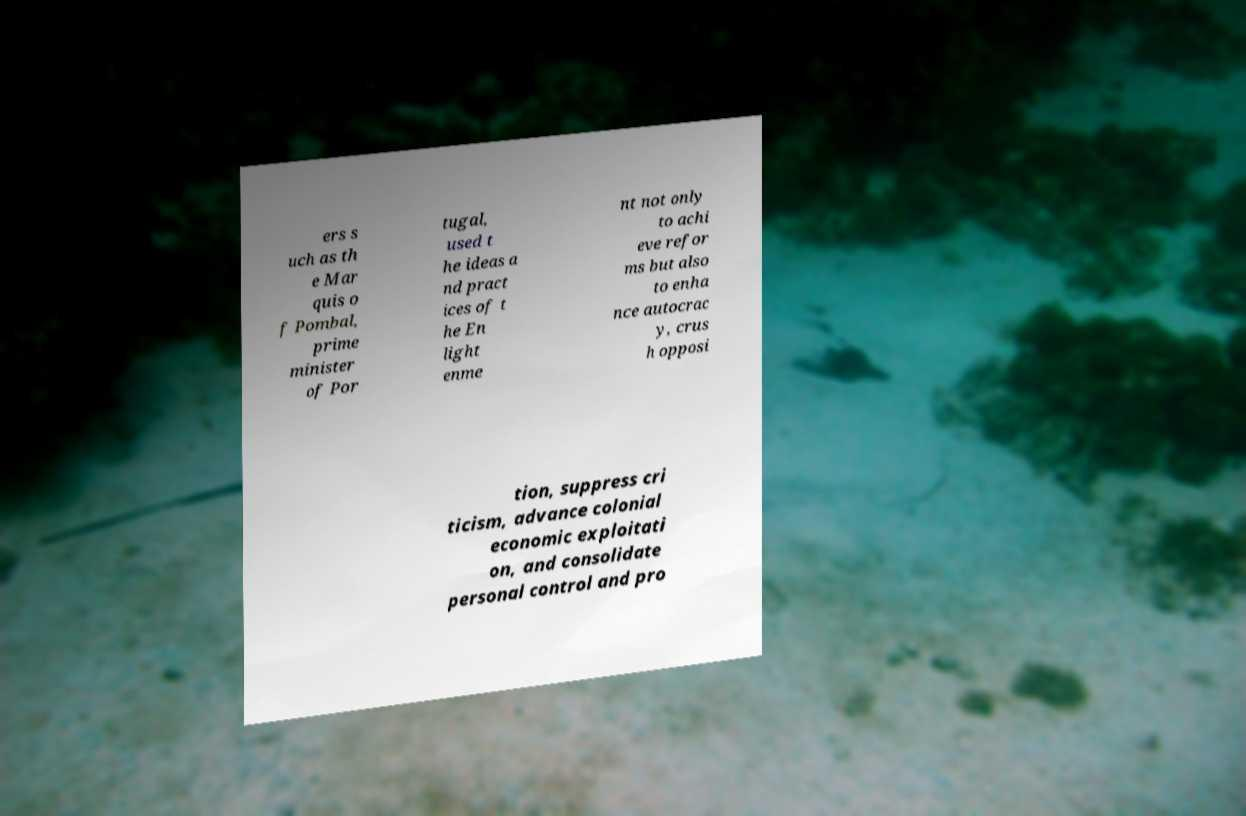What messages or text are displayed in this image? I need them in a readable, typed format. ers s uch as th e Mar quis o f Pombal, prime minister of Por tugal, used t he ideas a nd pract ices of t he En light enme nt not only to achi eve refor ms but also to enha nce autocrac y, crus h opposi tion, suppress cri ticism, advance colonial economic exploitati on, and consolidate personal control and pro 